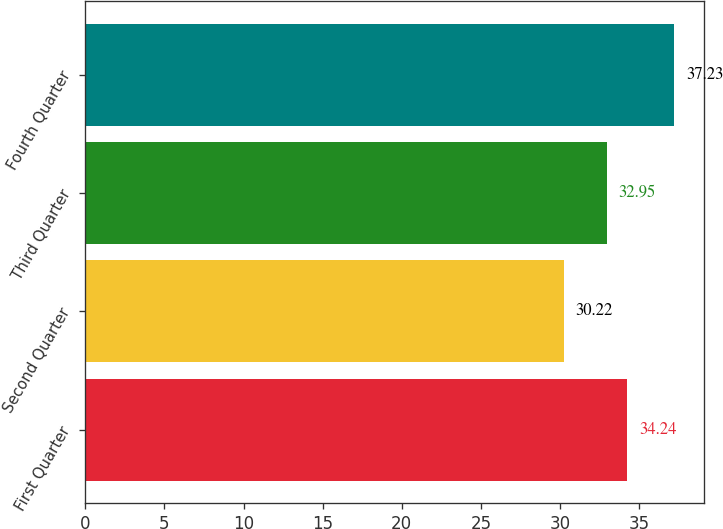Convert chart to OTSL. <chart><loc_0><loc_0><loc_500><loc_500><bar_chart><fcel>First Quarter<fcel>Second Quarter<fcel>Third Quarter<fcel>Fourth Quarter<nl><fcel>34.24<fcel>30.22<fcel>32.95<fcel>37.23<nl></chart> 